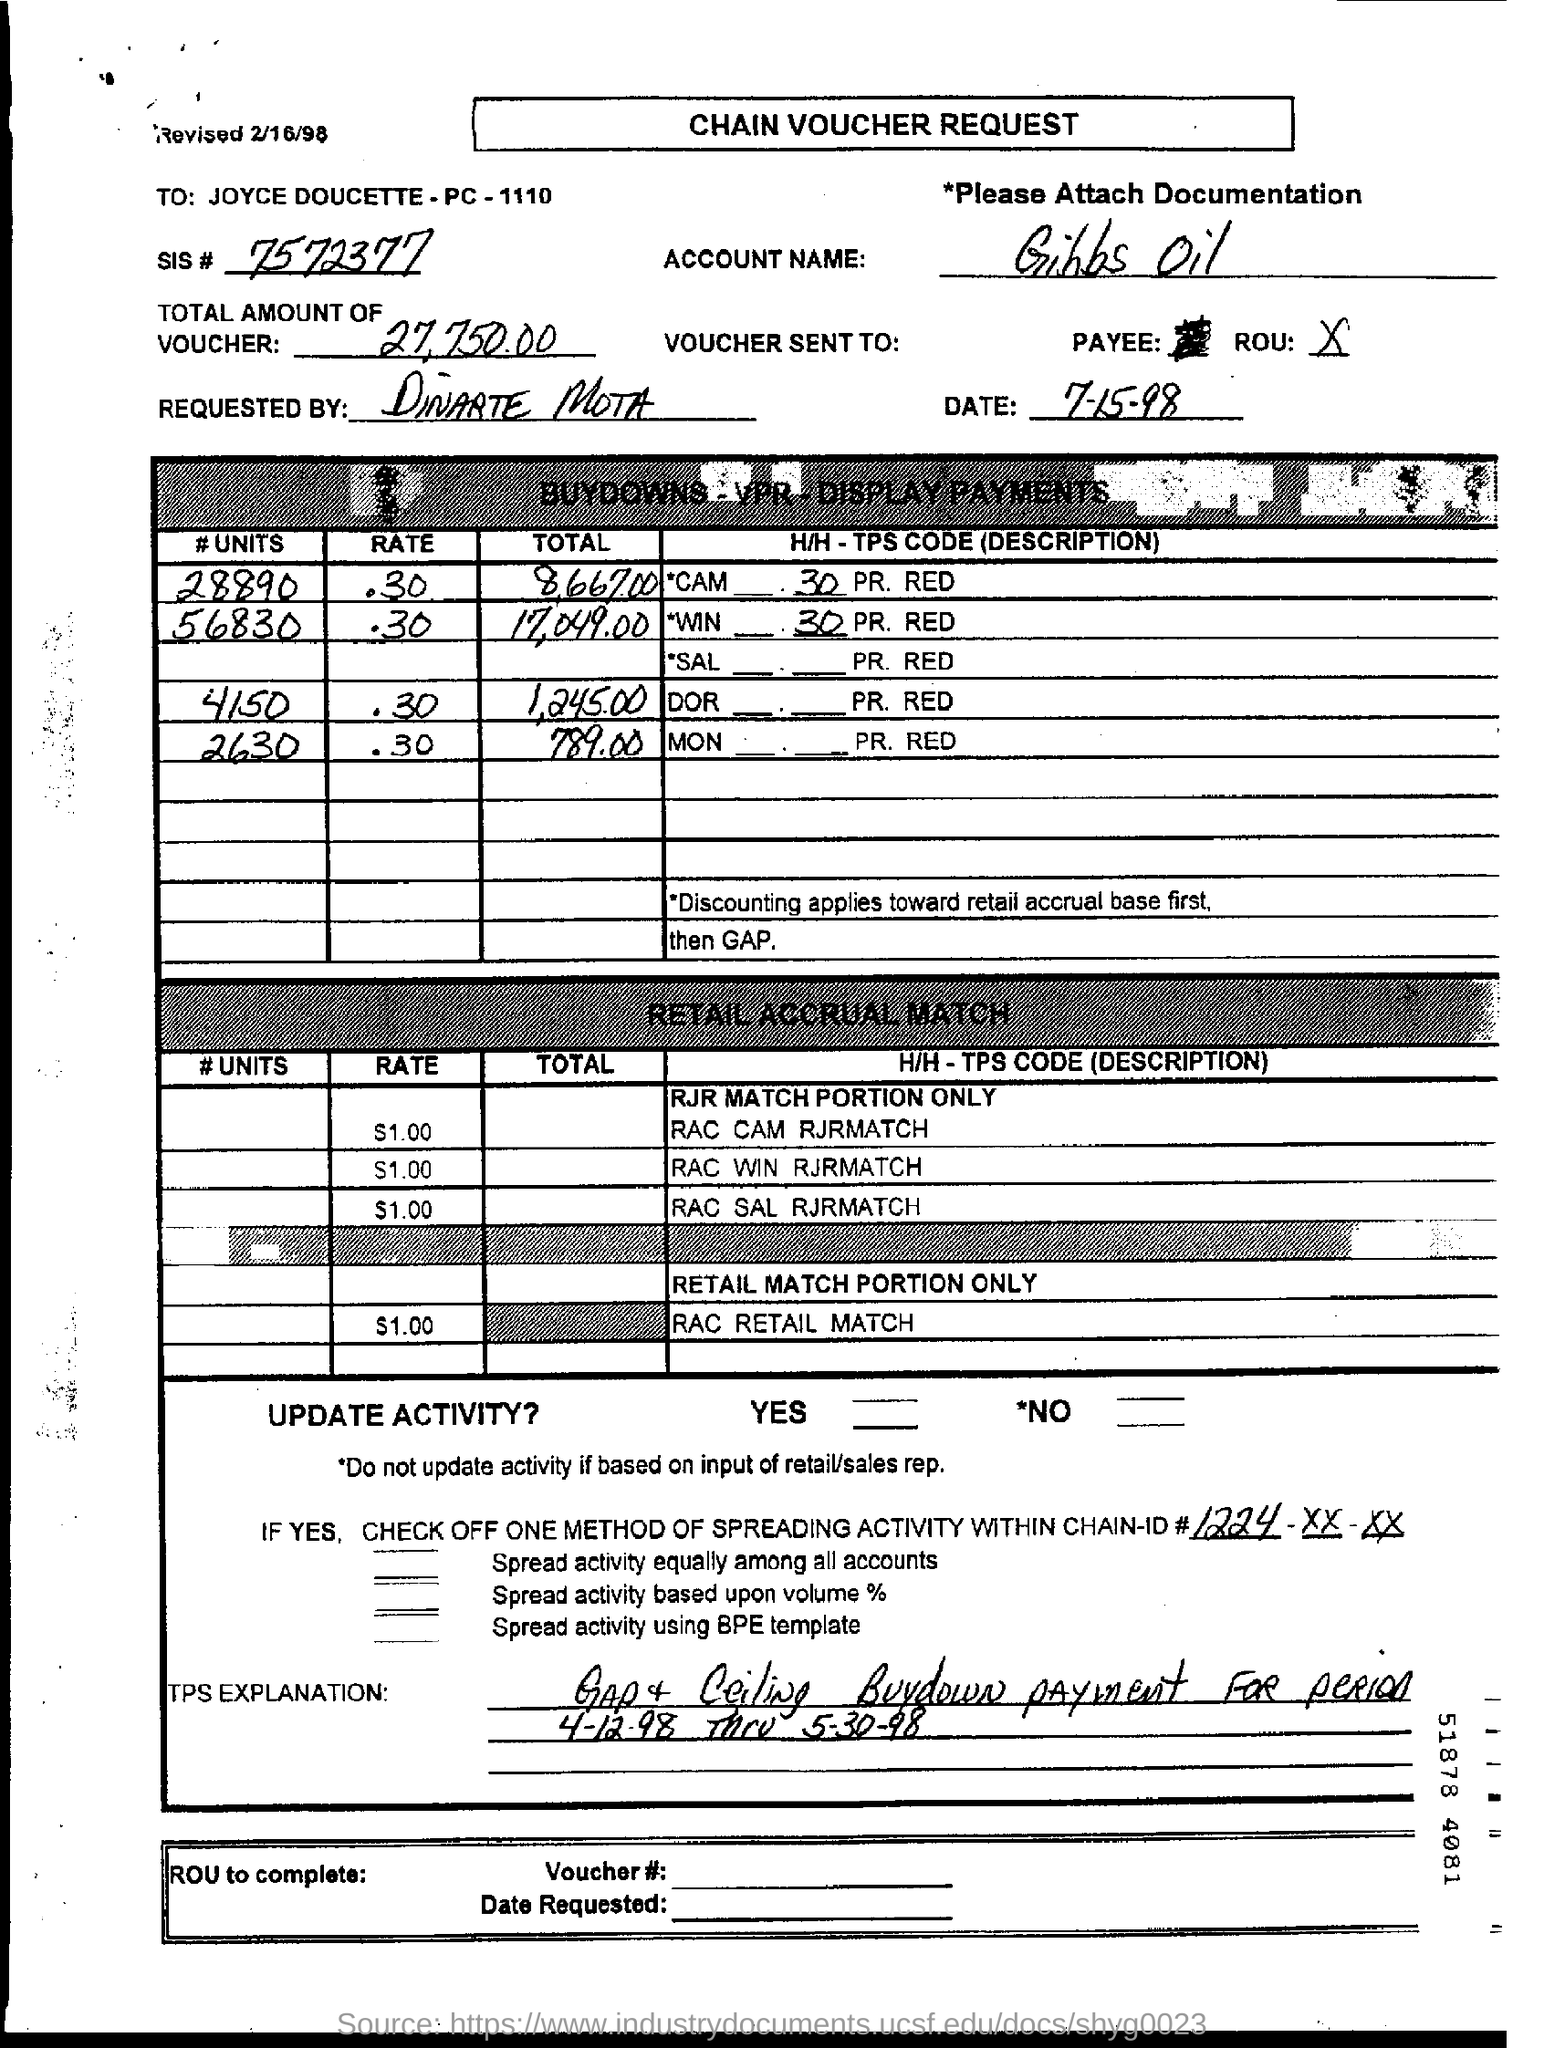Indicate a few pertinent items in this graphic. The account name mentioned is Gibbs Oil. The SIS number mentioned is 7572377... I am not sure what you are asking. Can you please clarify or provide more context? 